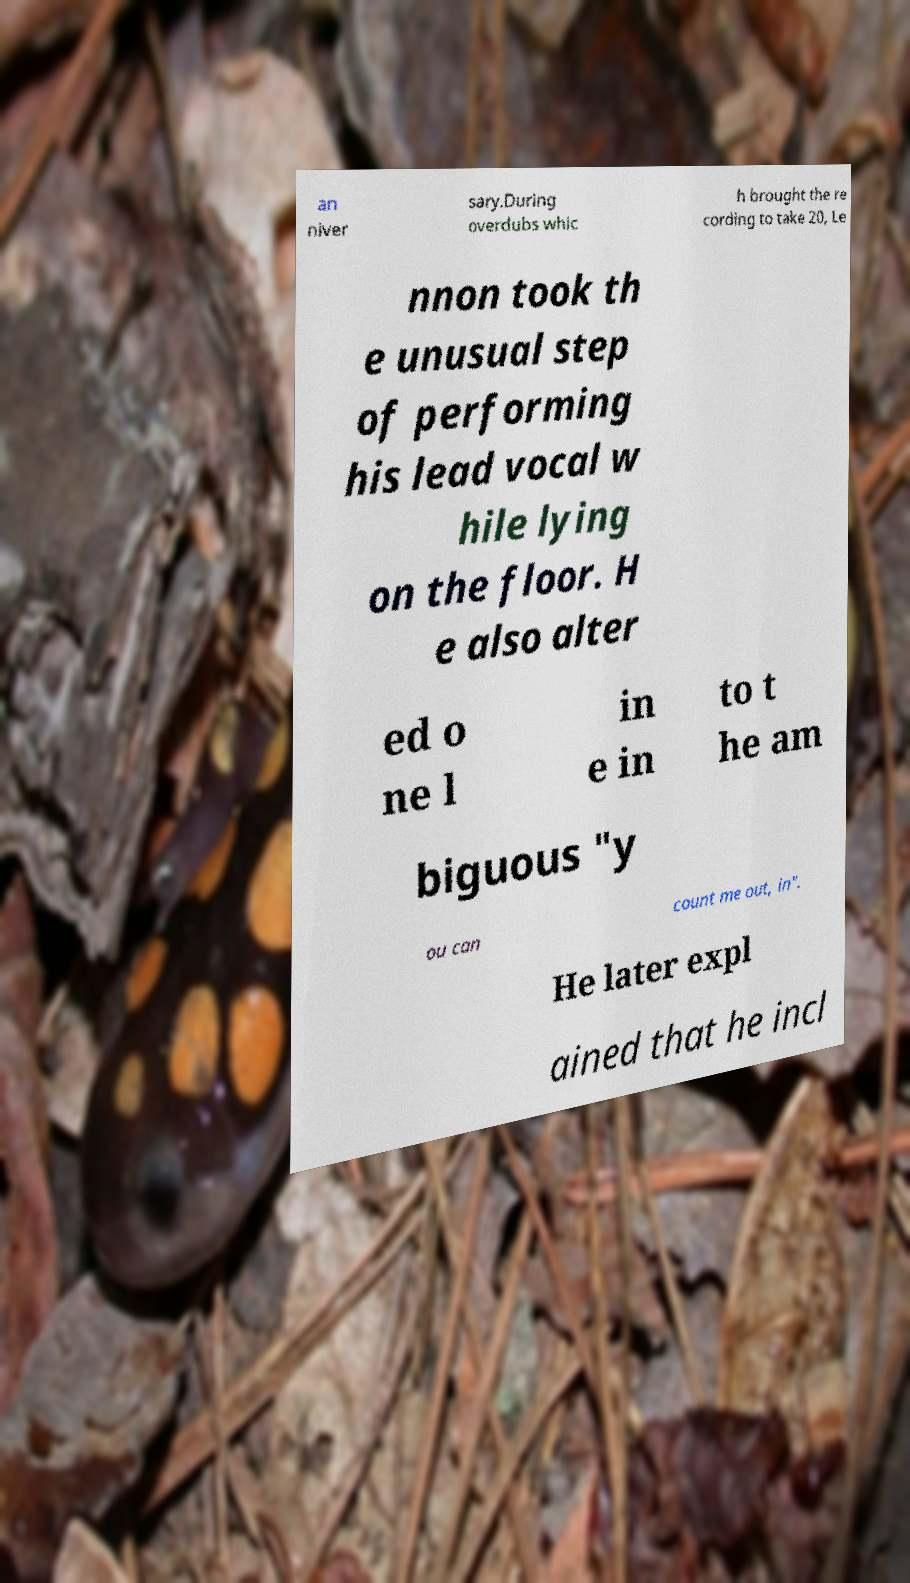There's text embedded in this image that I need extracted. Can you transcribe it verbatim? an niver sary.During overdubs whic h brought the re cording to take 20, Le nnon took th e unusual step of performing his lead vocal w hile lying on the floor. H e also alter ed o ne l in e in to t he am biguous "y ou can count me out, in". He later expl ained that he incl 